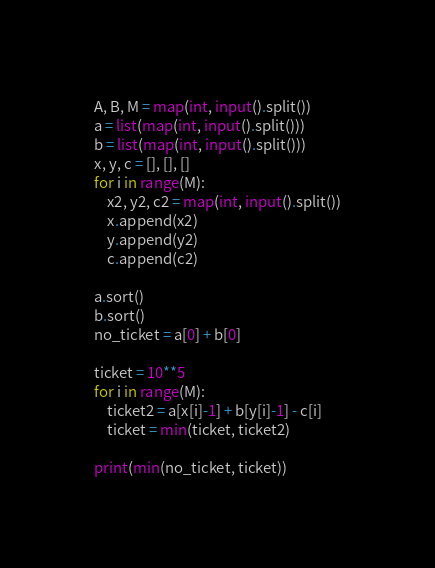Convert code to text. <code><loc_0><loc_0><loc_500><loc_500><_Python_>A, B, M = map(int, input().split())
a = list(map(int, input().split()))
b = list(map(int, input().split()))
x, y, c = [], [], []
for i in range(M):
    x2, y2, c2 = map(int, input().split())
    x.append(x2)
    y.append(y2)
    c.append(c2)

a.sort()
b.sort()
no_ticket = a[0] + b[0]

ticket = 10**5
for i in range(M):
    ticket2 = a[x[i]-1] + b[y[i]-1] - c[i]
    ticket = min(ticket, ticket2)

print(min(no_ticket, ticket))
</code> 